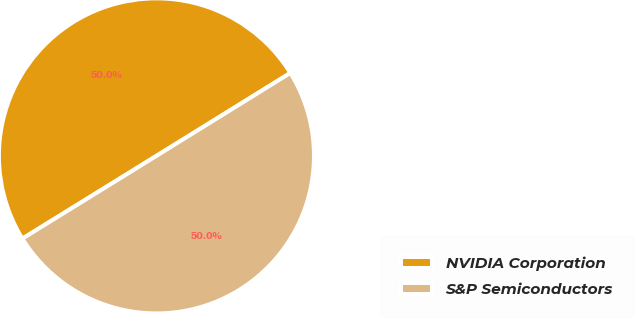<chart> <loc_0><loc_0><loc_500><loc_500><pie_chart><fcel>NVIDIA Corporation<fcel>S&P Semiconductors<nl><fcel>49.98%<fcel>50.02%<nl></chart> 